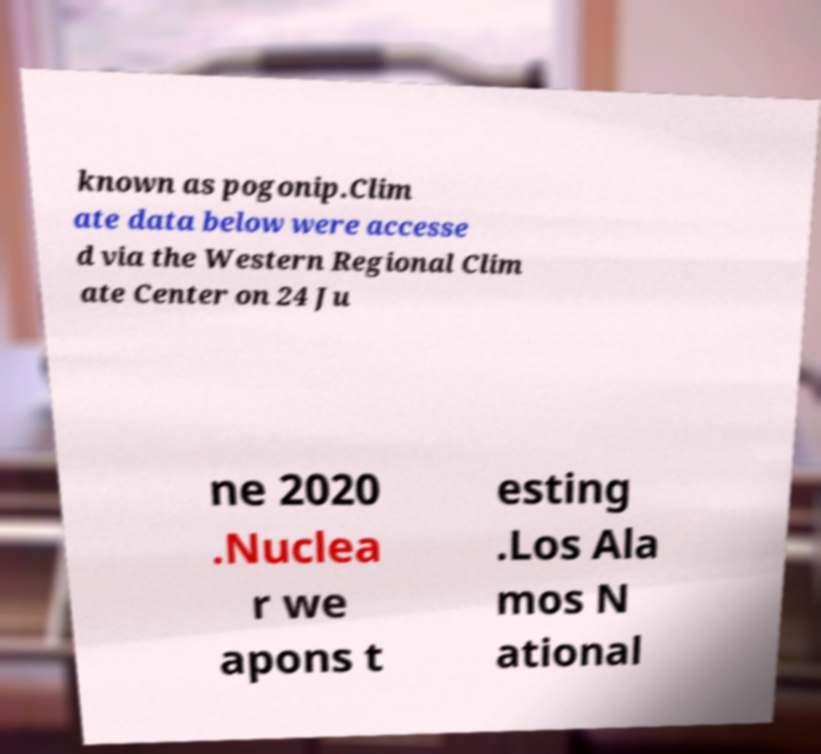I need the written content from this picture converted into text. Can you do that? known as pogonip.Clim ate data below were accesse d via the Western Regional Clim ate Center on 24 Ju ne 2020 .Nuclea r we apons t esting .Los Ala mos N ational 